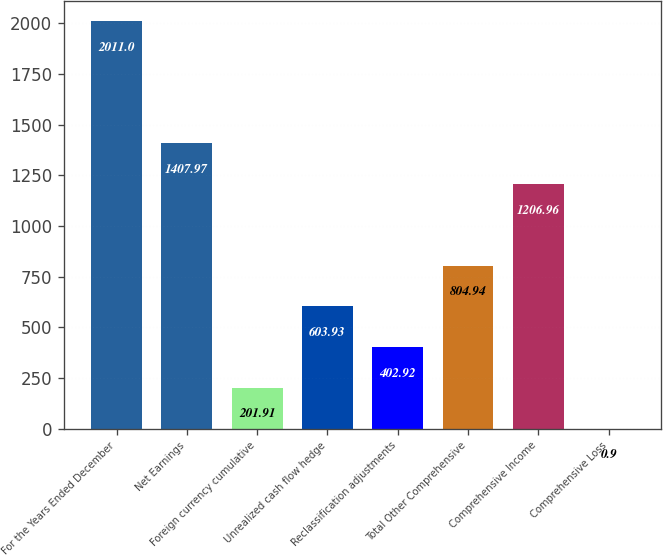Convert chart to OTSL. <chart><loc_0><loc_0><loc_500><loc_500><bar_chart><fcel>For the Years Ended December<fcel>Net Earnings<fcel>Foreign currency cumulative<fcel>Unrealized cash flow hedge<fcel>Reclassification adjustments<fcel>Total Other Comprehensive<fcel>Comprehensive Income<fcel>Comprehensive Loss<nl><fcel>2011<fcel>1407.97<fcel>201.91<fcel>603.93<fcel>402.92<fcel>804.94<fcel>1206.96<fcel>0.9<nl></chart> 